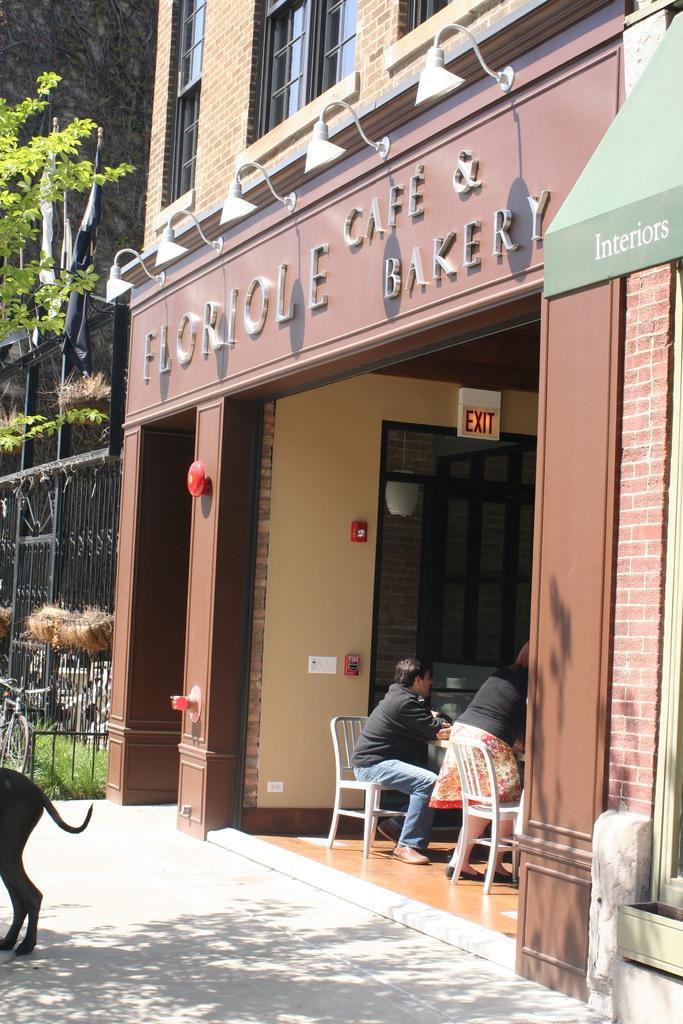How would you summarize this image in a sentence or two? there is a building in that building two persons are sitting in a chair there are some trees 